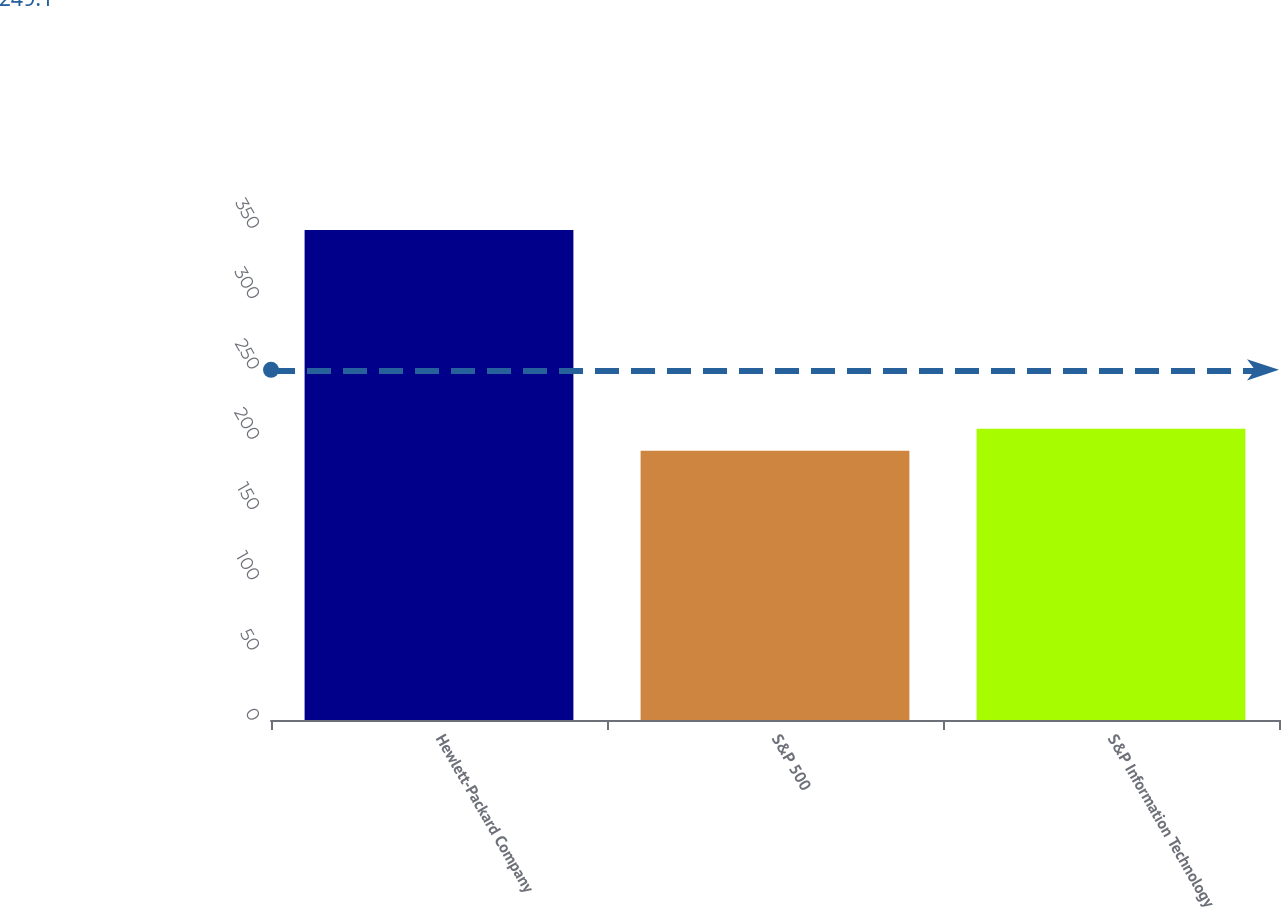<chart> <loc_0><loc_0><loc_500><loc_500><bar_chart><fcel>Hewlett-Packard Company<fcel>S&P 500<fcel>S&P Information Technology<nl><fcel>348.52<fcel>191.54<fcel>207.24<nl></chart> 